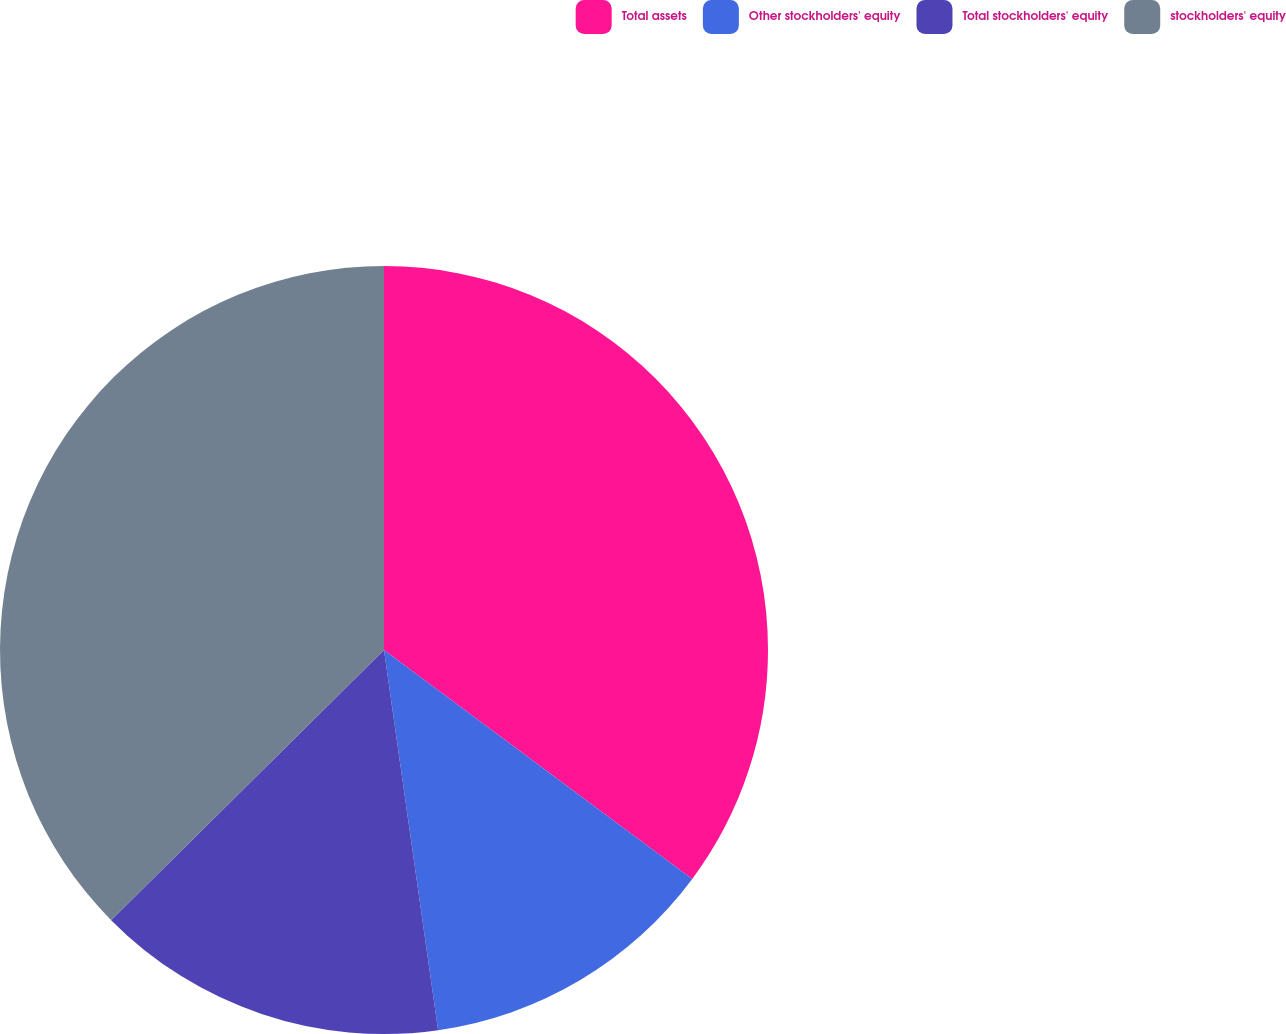Convert chart to OTSL. <chart><loc_0><loc_0><loc_500><loc_500><pie_chart><fcel>Total assets<fcel>Other stockholders' equity<fcel>Total stockholders' equity<fcel>stockholders' equity<nl><fcel>35.17%<fcel>12.58%<fcel>14.83%<fcel>37.42%<nl></chart> 